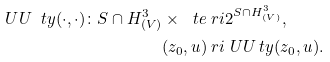<formula> <loc_0><loc_0><loc_500><loc_500>\ U U _ { \ } t y ( \cdot , \cdot ) \colon S \cap H ^ { 3 } _ { ( V ) } \times \ t e & \ r i 2 ^ { S \cap H ^ { 3 } _ { ( V ) } } , \\ ( z _ { 0 } , u ) & \ r i \ U U _ { \ } t y ( z _ { 0 } , u ) .</formula> 